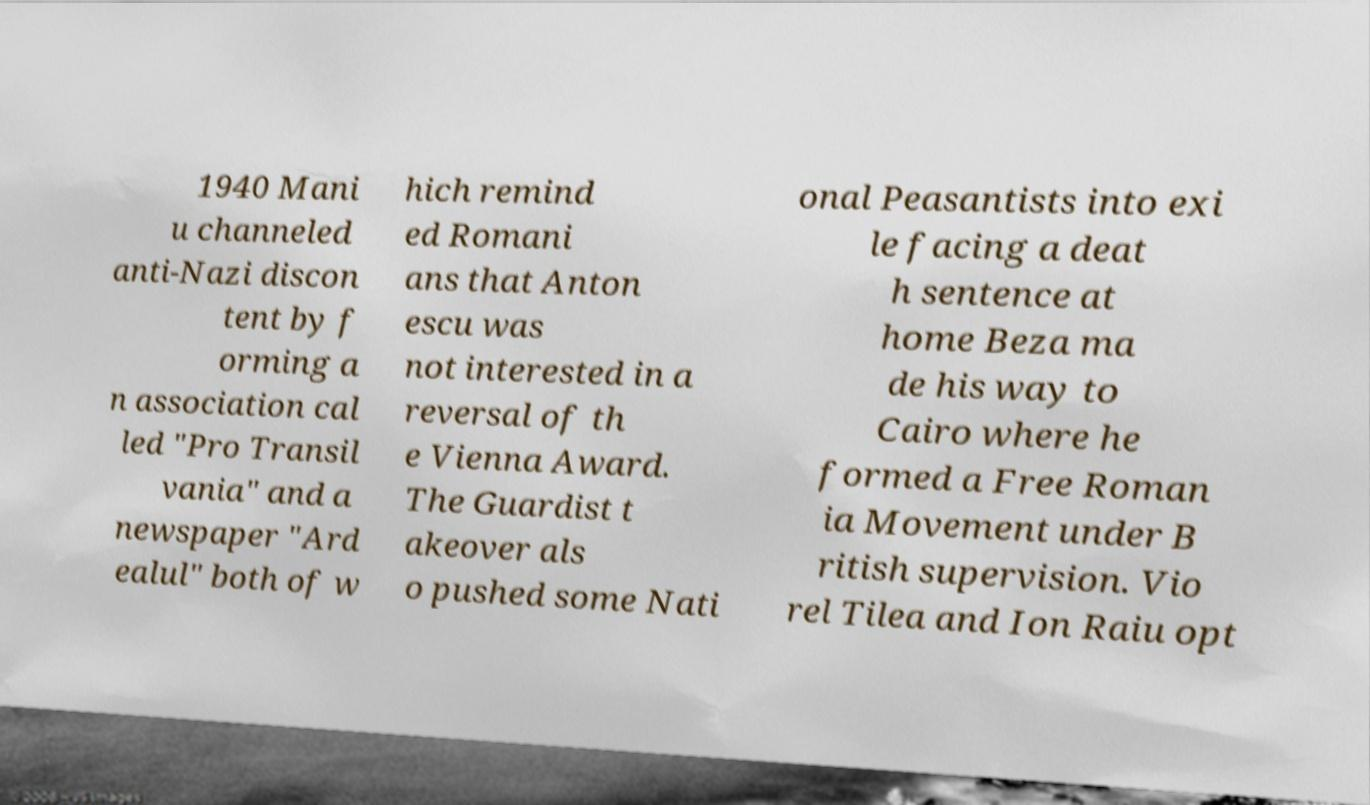For documentation purposes, I need the text within this image transcribed. Could you provide that? 1940 Mani u channeled anti-Nazi discon tent by f orming a n association cal led "Pro Transil vania" and a newspaper "Ard ealul" both of w hich remind ed Romani ans that Anton escu was not interested in a reversal of th e Vienna Award. The Guardist t akeover als o pushed some Nati onal Peasantists into exi le facing a deat h sentence at home Beza ma de his way to Cairo where he formed a Free Roman ia Movement under B ritish supervision. Vio rel Tilea and Ion Raiu opt 